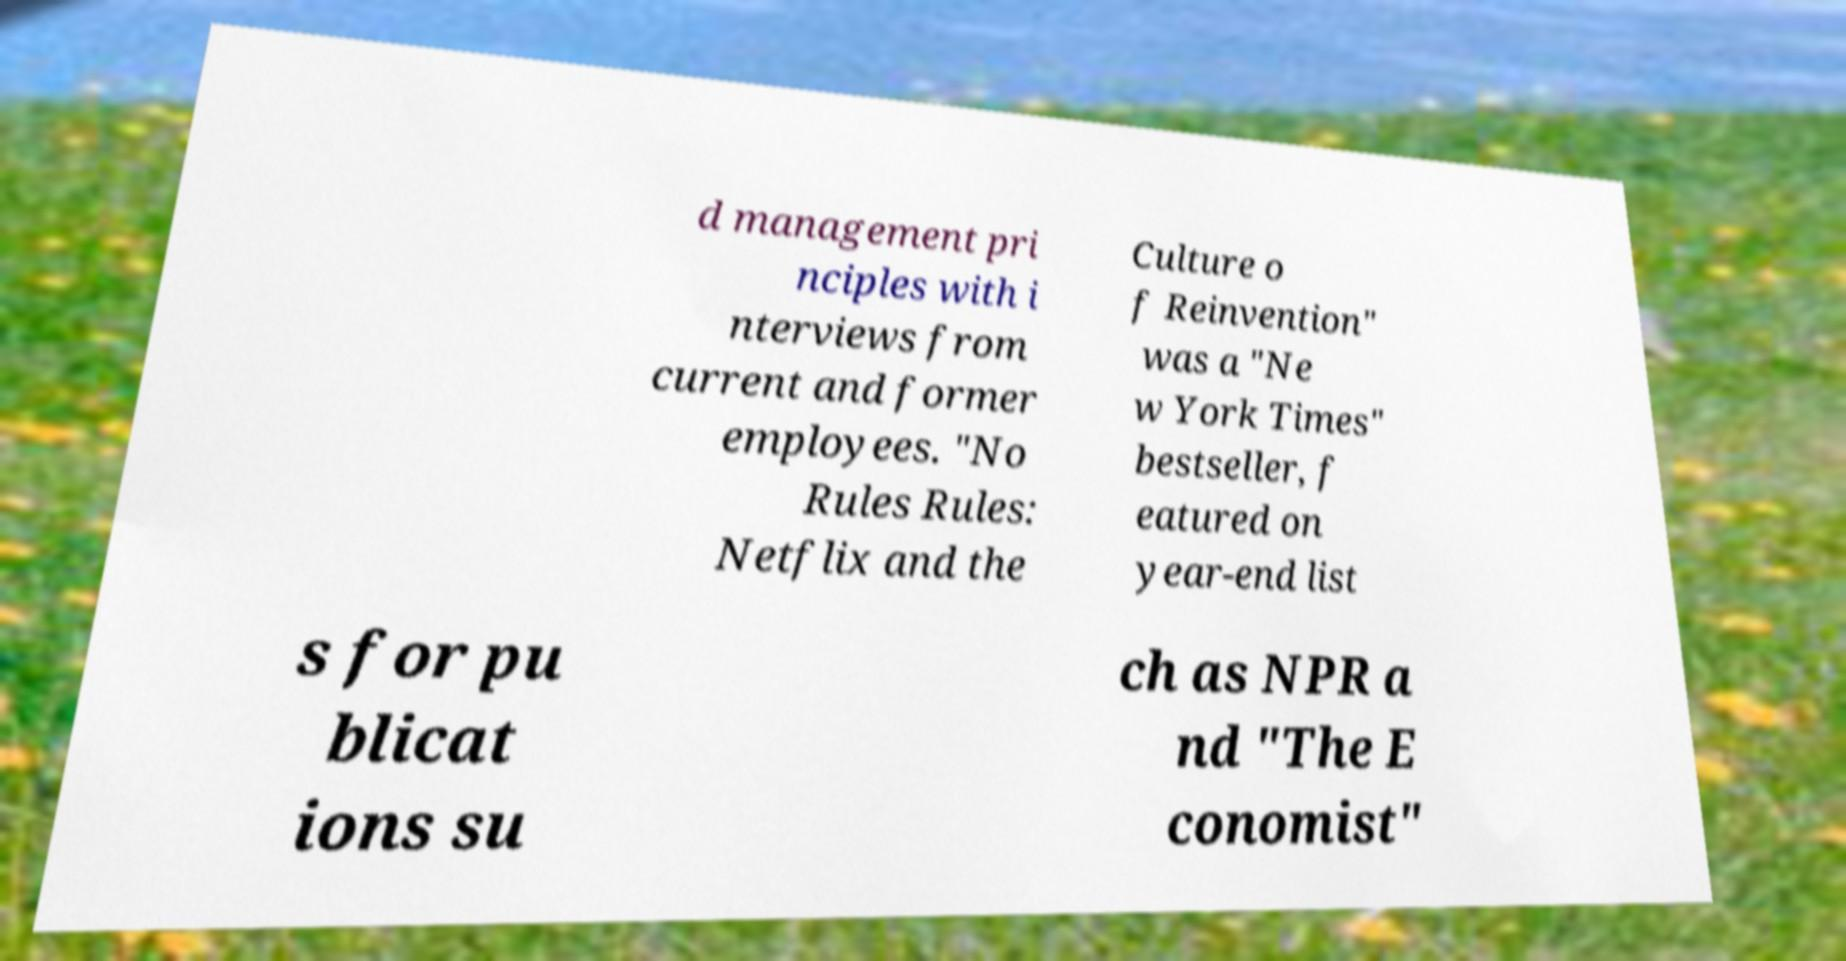There's text embedded in this image that I need extracted. Can you transcribe it verbatim? d management pri nciples with i nterviews from current and former employees. "No Rules Rules: Netflix and the Culture o f Reinvention" was a "Ne w York Times" bestseller, f eatured on year-end list s for pu blicat ions su ch as NPR a nd "The E conomist" 